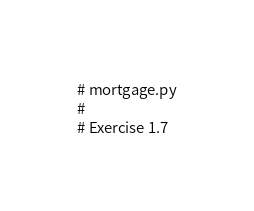<code> <loc_0><loc_0><loc_500><loc_500><_Python_># mortgage.py
#
# Exercise 1.7
</code> 